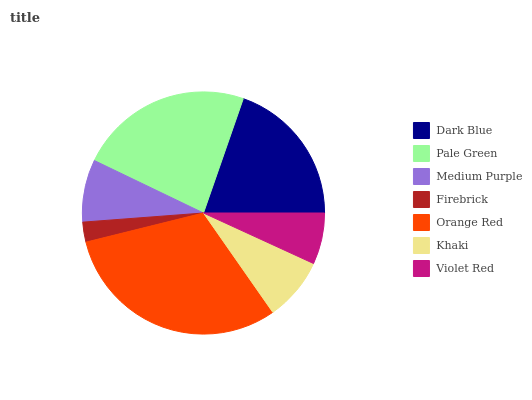Is Firebrick the minimum?
Answer yes or no. Yes. Is Orange Red the maximum?
Answer yes or no. Yes. Is Pale Green the minimum?
Answer yes or no. No. Is Pale Green the maximum?
Answer yes or no. No. Is Pale Green greater than Dark Blue?
Answer yes or no. Yes. Is Dark Blue less than Pale Green?
Answer yes or no. Yes. Is Dark Blue greater than Pale Green?
Answer yes or no. No. Is Pale Green less than Dark Blue?
Answer yes or no. No. Is Khaki the high median?
Answer yes or no. Yes. Is Khaki the low median?
Answer yes or no. Yes. Is Pale Green the high median?
Answer yes or no. No. Is Orange Red the low median?
Answer yes or no. No. 